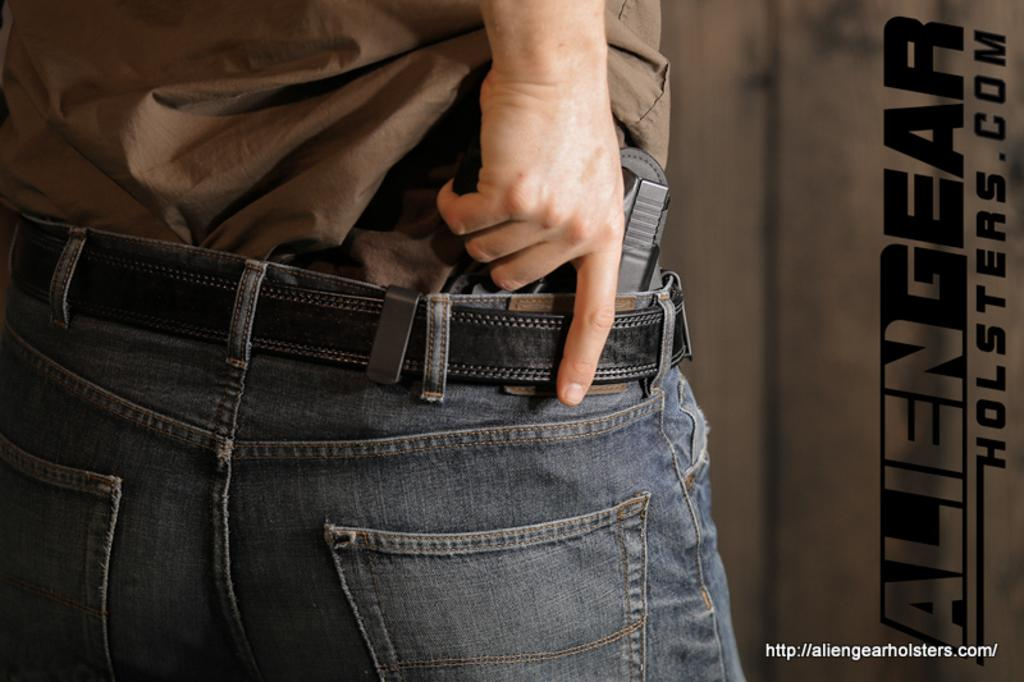Who or what is present in the image? There is a person in the image. What is the person doing in the image? The person is standing. What is the person holding in the image? The person is holding a weapon. What type of market can be seen in the background of the image? There is no market visible in the image; it only features a person standing and holding a weapon. How many things are present on the horse in the image? There is no horse present in the image. 